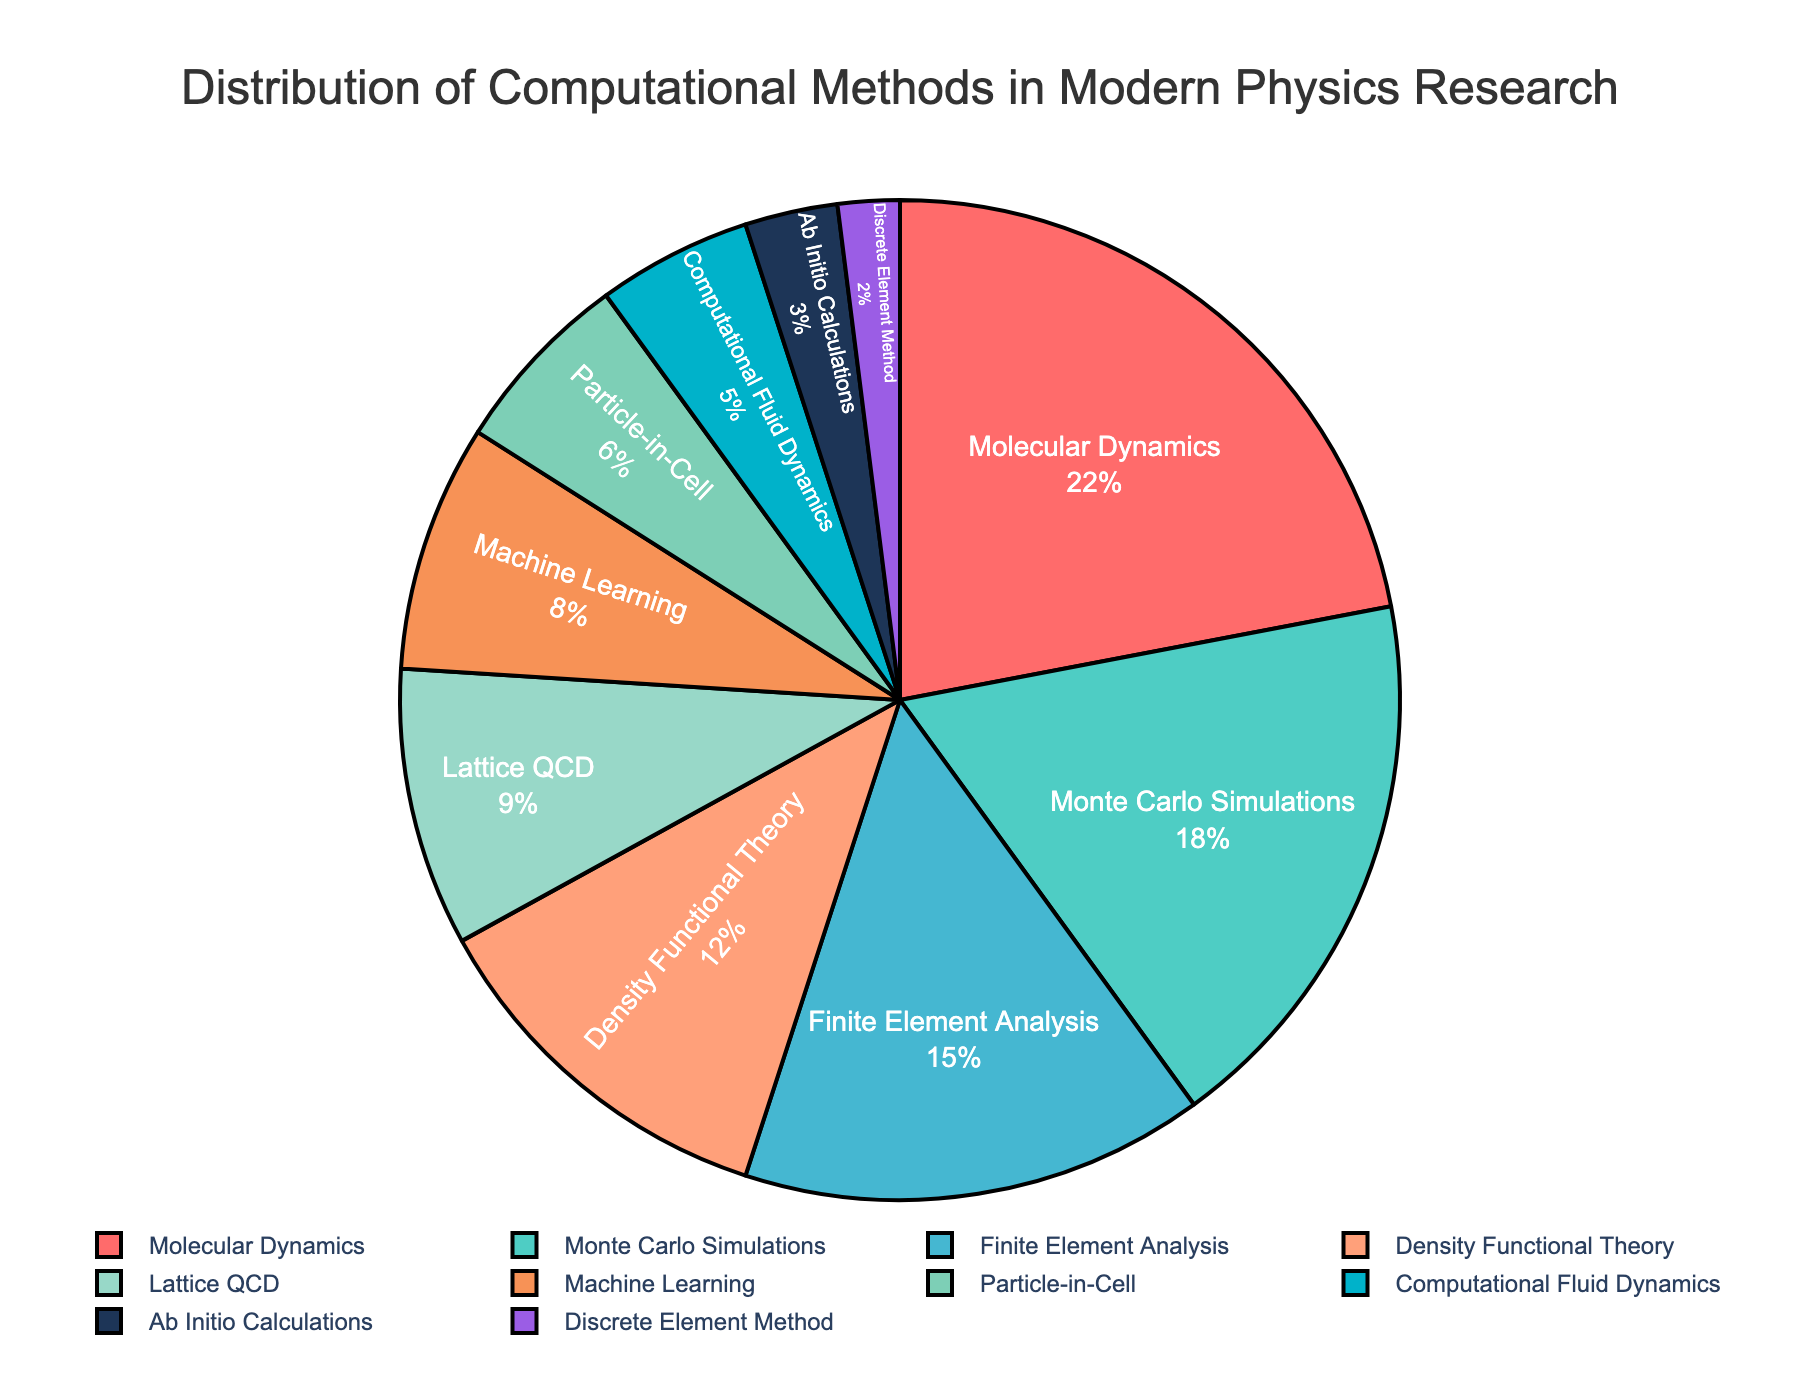What computational method occupies the largest portion of the pie chart? By examining the figure, we can identify the section with the largest area, which corresponds to Molecular Dynamics at 22%.
Answer: Molecular Dynamics Which is more utilized, Machine Learning or Lattice QCD? By comparing their respective segments in the pie chart, Lattice QCD at 9% is more utilized than Machine Learning at 8%.
Answer: Lattice QCD What is the total percentage for Monte Carlo Simulations and Finite Element Analysis together? Summing the percentages for Monte Carlo Simulations (18%) and Finite Element Analysis (15%) gives 33%.
Answer: 33% Which method is represented by the smallest portion of the pie chart? The slice with the smallest area belongs to Discrete Element Method at 2%.
Answer: Discrete Element Method How much more is Molecular Dynamics utilized compared to Ab Initio Calculations? Subtract the percentage for Ab Initio Calculations (3%) from Molecular Dynamics (22%) to get 19%.
Answer: 19% What computational methods are represented by shades of blue in the pie chart? By examining the colors used for the slices, the methods in shades of blue are Density Functional Theory, Lattice QCD, and Computational Fluid Dynamics.
Answer: Density Functional Theory, Lattice QCD, Computational Fluid Dynamics What percentage of methods fall below Machine Learning in utilization? Sum the percentages for Particle-in-Cell (6%), Computational Fluid Dynamics (5%), Ab Initio Calculations (3%), and Discrete Element Method (2%) to get 16%.
Answer: 16% Which method has a darker color in the pie chart, Monte Carlo Simulations or Density Functional Theory? The visual inspection shows that Monte Carlo Simulations is represented by a darker color (#4ECDC4) than Density Functional Theory.
Answer: Monte Carlo Simulations What is the combined percentage of the three most utilized methods? Adding the percentages for Molecular Dynamics (22%), Monte Carlo Simulations (18%), and Finite Element Analysis (15%) results in a total of 55%.
Answer: 55% 